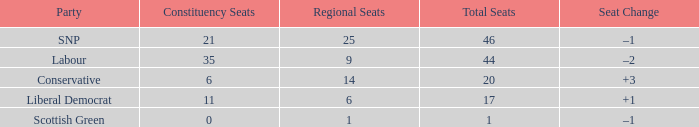How many regional seats did the snp party have where the total number of seats exceeded 46? 0.0. 